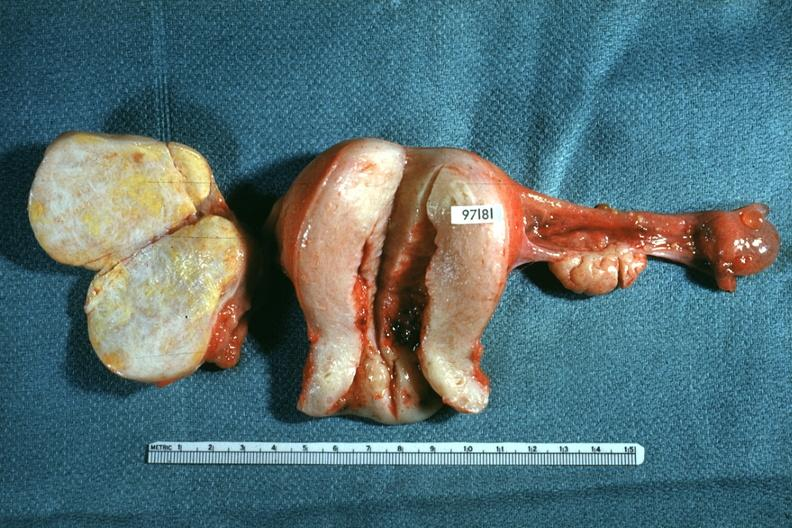does this image show ovaries and uterus with tumor mass?
Answer the question using a single word or phrase. Yes 